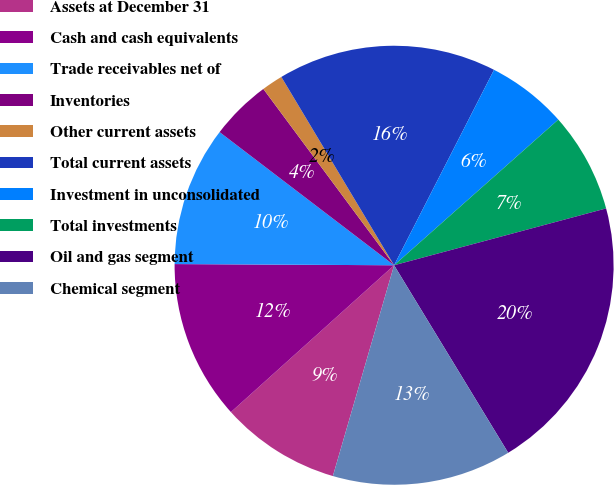Convert chart. <chart><loc_0><loc_0><loc_500><loc_500><pie_chart><fcel>Assets at December 31<fcel>Cash and cash equivalents<fcel>Trade receivables net of<fcel>Inventories<fcel>Other current assets<fcel>Total current assets<fcel>Investment in unconsolidated<fcel>Total investments<fcel>Oil and gas segment<fcel>Chemical segment<nl><fcel>8.84%<fcel>11.75%<fcel>10.29%<fcel>4.47%<fcel>1.57%<fcel>16.11%<fcel>5.93%<fcel>7.38%<fcel>20.47%<fcel>13.2%<nl></chart> 